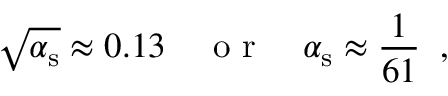Convert formula to latex. <formula><loc_0><loc_0><loc_500><loc_500>\sqrt { \alpha _ { s } } \approx 0 . 1 3 \quad o r \quad \alpha _ { s } \approx \frac { 1 } { 6 1 } \, ,</formula> 